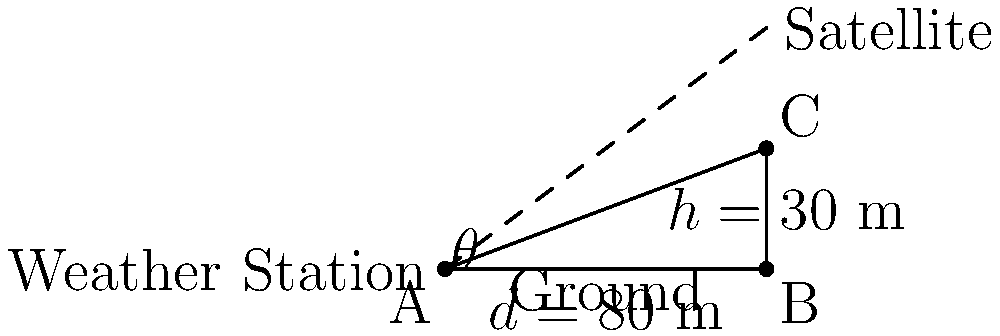A weather station is installing a new antenna to receive satellite signals for improved data collection. The antenna needs to be angled for optimal reception. The satellite is directly above a point 80 meters away from the base of the weather station tower. If the antenna is mounted at the top of the 30-meter tall tower, what is the angle of elevation $\theta$ (in degrees) at which the antenna should be positioned for optimal signal reception? Let's approach this step-by-step:

1) We can treat this as a right-angled triangle problem, where:
   - The base of the triangle (d) is 80 meters (distance to the point above which the satellite is located)
   - The height of the triangle (h) is 30 meters (height of the tower)
   - The angle we're looking for (θ) is the angle of elevation

2) In a right-angled triangle, we can use the tangent function to find the angle:

   $\tan(\theta) = \frac{\text{opposite}}{\text{adjacent}} = \frac{h}{d}$

3) Substituting our known values:

   $\tan(\theta) = \frac{30}{80}$

4) To find θ, we need to use the inverse tangent (arctan or $\tan^{-1}$):

   $\theta = \tan^{-1}(\frac{30}{80})$

5) Using a calculator or computer:

   $\theta = \tan^{-1}(0.375) \approx 20.556$ degrees

6) Rounding to two decimal places:

   $\theta \approx 20.56$ degrees

Therefore, the antenna should be positioned at an angle of elevation of approximately 20.56 degrees for optimal signal reception.
Answer: $20.56°$ 